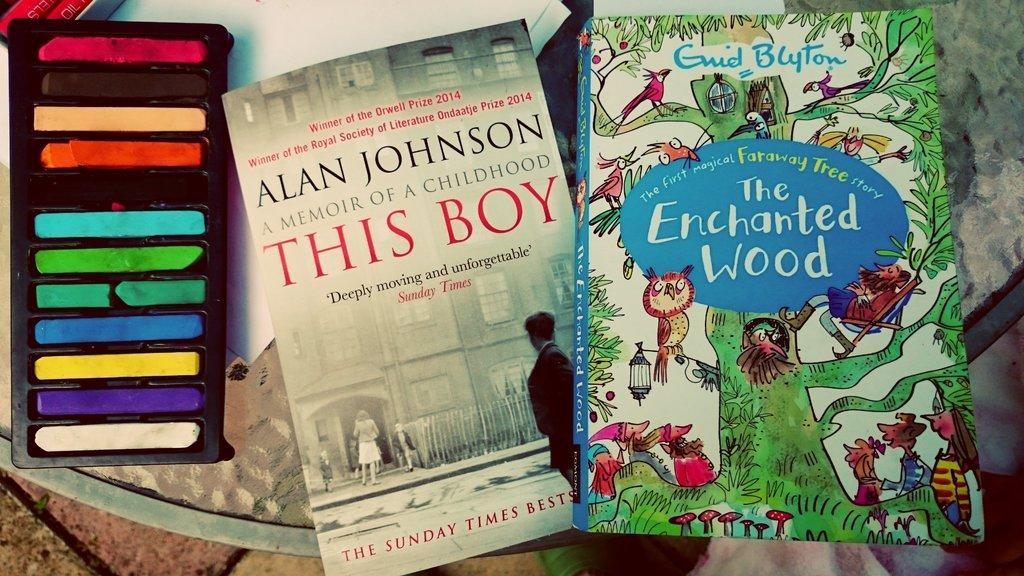Can you describe this image briefly? In this image there are books and colors. 